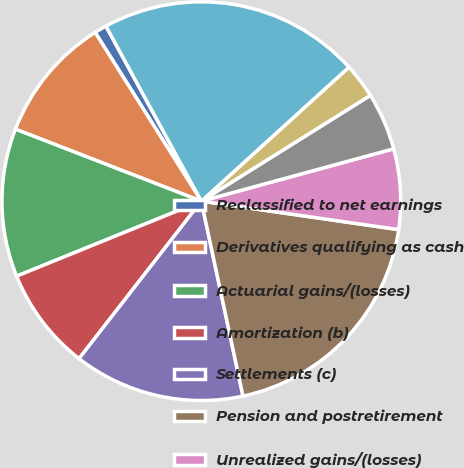Convert chart to OTSL. <chart><loc_0><loc_0><loc_500><loc_500><pie_chart><fcel>Reclassified to net earnings<fcel>Derivatives qualifying as cash<fcel>Actuarial gains/(losses)<fcel>Amortization (b)<fcel>Settlements (c)<fcel>Pension and postretirement<fcel>Unrealized gains/(losses)<fcel>Available-for-sale securities<fcel>Foreign currency translation<fcel>Total Other Comprehensive<nl><fcel>1.0%<fcel>10.18%<fcel>12.02%<fcel>8.35%<fcel>13.86%<fcel>19.37%<fcel>6.51%<fcel>4.67%<fcel>2.83%<fcel>21.21%<nl></chart> 